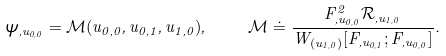<formula> <loc_0><loc_0><loc_500><loc_500>\psi _ { , u _ { 0 , 0 } } = \mathcal { M } ( u _ { 0 , 0 } , u _ { 0 , 1 } , u _ { 1 , 0 } ) , \quad \mathcal { M } \doteq \frac { F _ { , u _ { 0 , 0 } } ^ { 2 } \mathcal { R } _ { , u _ { 1 , 0 } } } { W _ { ( u _ { 1 , 0 } ) } [ F _ { , u _ { 0 , 1 } } ; F _ { , u _ { 0 , 0 } } ] } .</formula> 